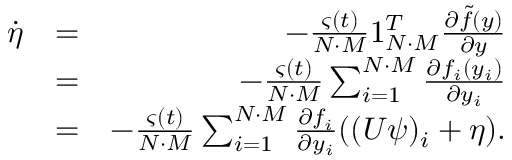Convert formula to latex. <formula><loc_0><loc_0><loc_500><loc_500>\begin{array} { r l r } { \dot { \eta } } & { = } & { - \frac { \varsigma ( t ) } { N \cdot M } 1 _ { N \cdot M } ^ { T } \frac { \partial \tilde { f } ( y ) } { \partial y } } \\ & { = } & { - \frac { \varsigma ( t ) } { N \cdot M } \sum _ { i = 1 } ^ { N \cdot M } \frac { \partial f _ { i } ( y _ { i } ) } { \partial y _ { i } } } \\ & { = } & { - \frac { \varsigma ( t ) } { N \cdot M } \sum _ { i = 1 } ^ { N \cdot M } \frac { \partial f _ { i } } { \partial y _ { i } } ( ( U \psi ) _ { i } + \eta ) . } \end{array}</formula> 